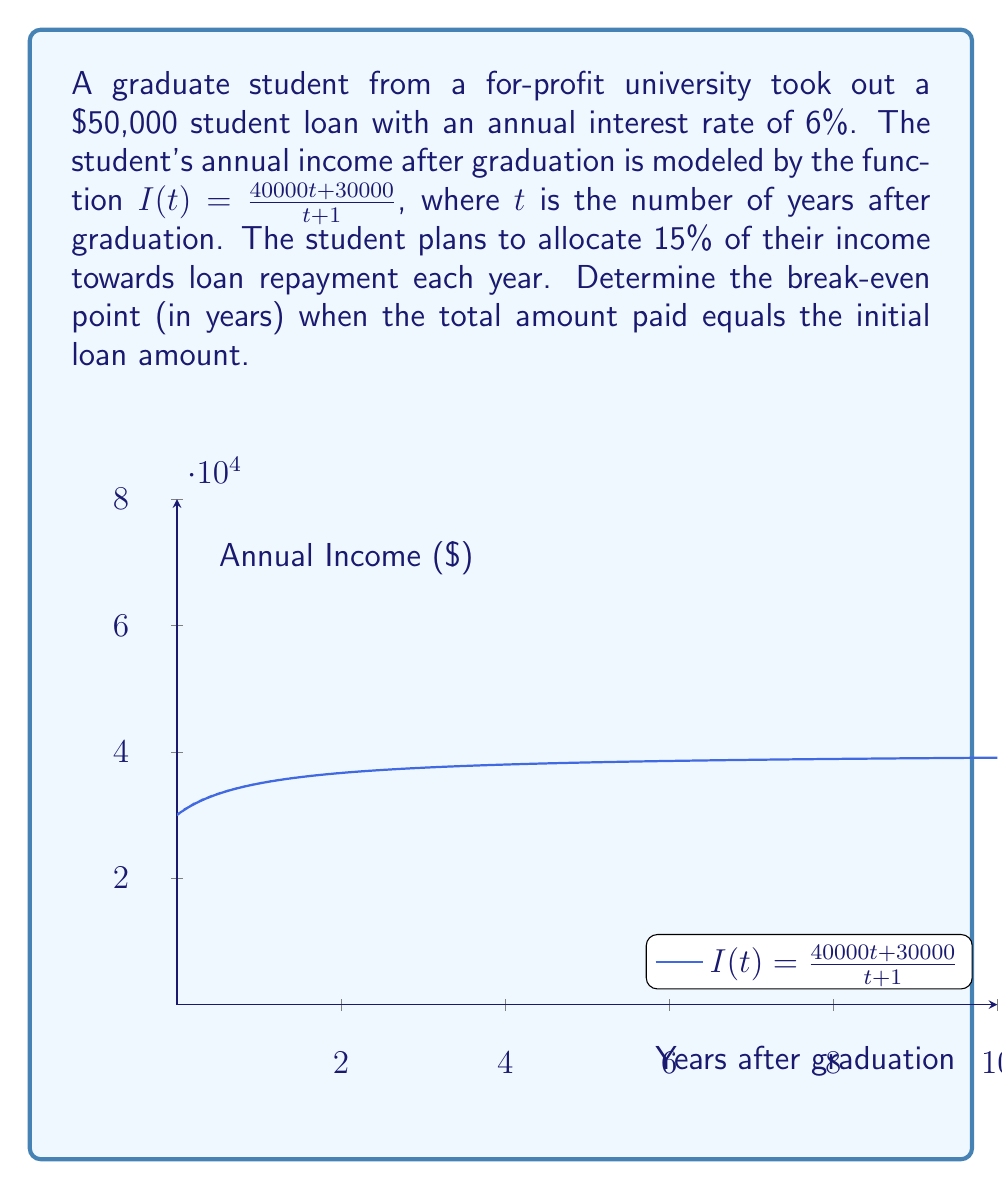Could you help me with this problem? Let's approach this step-by-step:

1) The annual payment is 15% of the income. We can express this as a function of time:
   $P(t) = 0.15 \cdot I(t) = 0.15 \cdot \frac{40000t + 30000}{t + 1}$

2) The total amount paid after $t$ years is the integral of $P(t)$ from 0 to $t$:
   $T(t) = \int_0^t P(x) dx = 0.15 \int_0^t \frac{40000x + 30000}{x + 1} dx$

3) To solve this integral, we can use partial fractions decomposition:
   $\frac{40000x + 30000}{x + 1} = 40000 - \frac{10000}{x + 1}$

4) Now our integral becomes:
   $T(t) = 0.15 \int_0^t (40000 - \frac{10000}{x + 1}) dx$

5) Solving this integral:
   $T(t) = 0.15 [40000x - 10000\ln(x+1)]_0^t$
   $T(t) = 0.15 [40000t - 10000\ln(t+1) + 10000\ln(1)]$
   $T(t) = 6000t - 1500\ln(t+1)$

6) The break-even point occurs when $T(t) = 50000$. So we need to solve:
   $50000 = 6000t - 1500\ln(t+1)$

7) This equation cannot be solved algebraically. We need to use numerical methods or graphing to find the solution.

8) Using a graphing calculator or software, we can find that the solution is approximately $t = 9.16$ years.
Answer: 9.16 years 